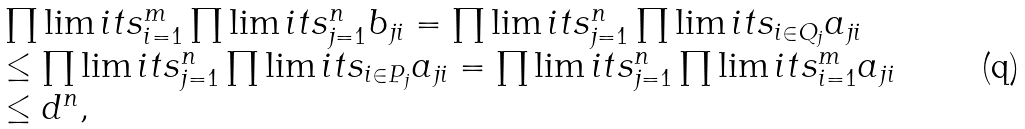<formula> <loc_0><loc_0><loc_500><loc_500>\begin{array} { l } \prod \lim i t s _ { i = 1 } ^ { m } \prod \lim i t s _ { j = 1 } ^ { n } { b _ { j i } } = \prod \lim i t s _ { j = 1 } ^ { n } \prod \lim i t s _ { i \in Q _ { j } } { a _ { j i } } \\ \leq \prod \lim i t s _ { j = 1 } ^ { n } \prod \lim i t s _ { i \in P _ { j } } { a _ { j i } } = \prod \lim i t s _ { j = 1 } ^ { n } \prod \lim i t s _ { i = 1 } ^ { m } { a _ { j i } } \\ \leq d ^ { n } , \end{array}</formula> 